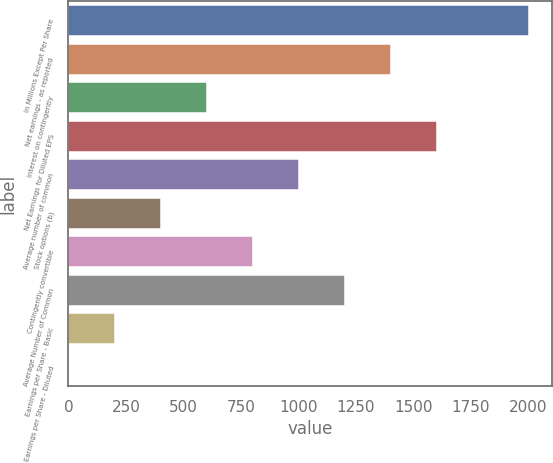Convert chart. <chart><loc_0><loc_0><loc_500><loc_500><bar_chart><fcel>In Millions Except Per Share<fcel>Net earnings - as reported<fcel>Interest on contingently<fcel>Net Earnings for Diluted EPS<fcel>Average number of common<fcel>Stock options (b)<fcel>Contingently convertible<fcel>Average Number of Common<fcel>Earnings per Share - Basic<fcel>Earnings per Share - Diluted<nl><fcel>2004<fcel>1403.58<fcel>603.02<fcel>1603.72<fcel>1003.3<fcel>402.88<fcel>803.16<fcel>1203.44<fcel>202.74<fcel>2.6<nl></chart> 